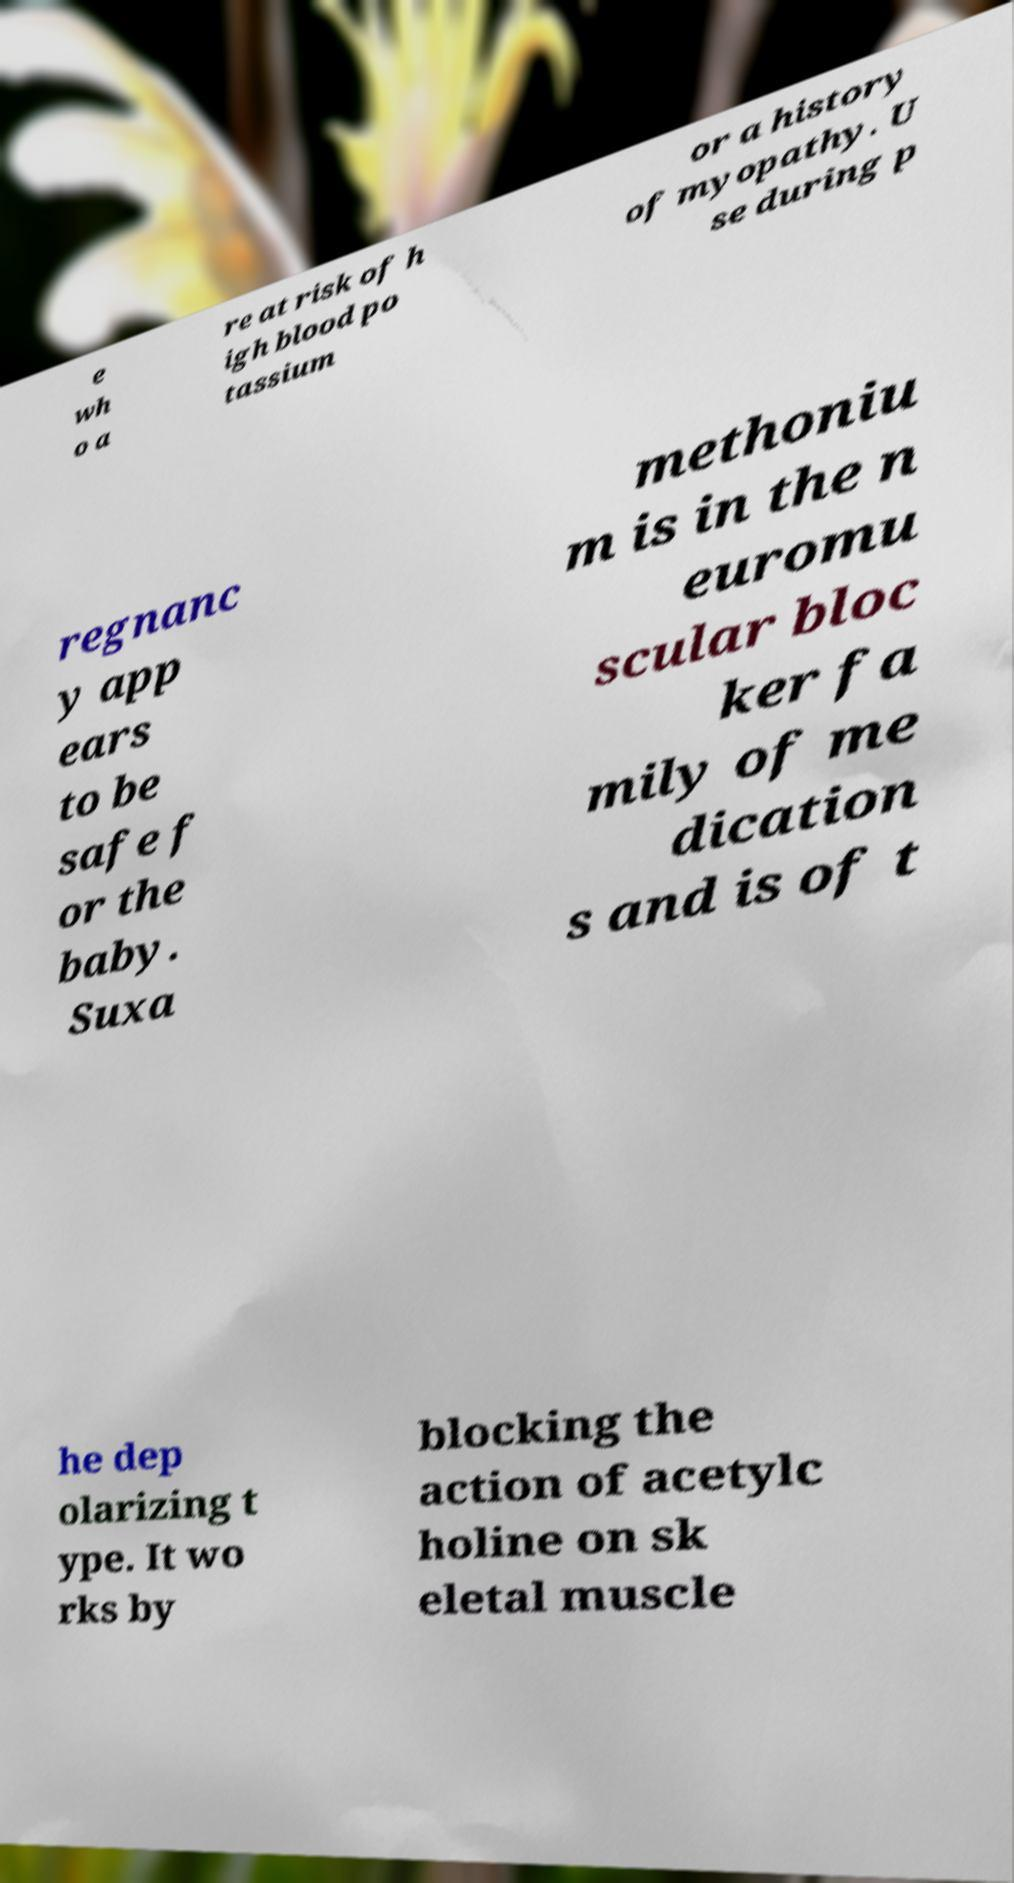There's text embedded in this image that I need extracted. Can you transcribe it verbatim? e wh o a re at risk of h igh blood po tassium or a history of myopathy. U se during p regnanc y app ears to be safe f or the baby. Suxa methoniu m is in the n euromu scular bloc ker fa mily of me dication s and is of t he dep olarizing t ype. It wo rks by blocking the action of acetylc holine on sk eletal muscle 